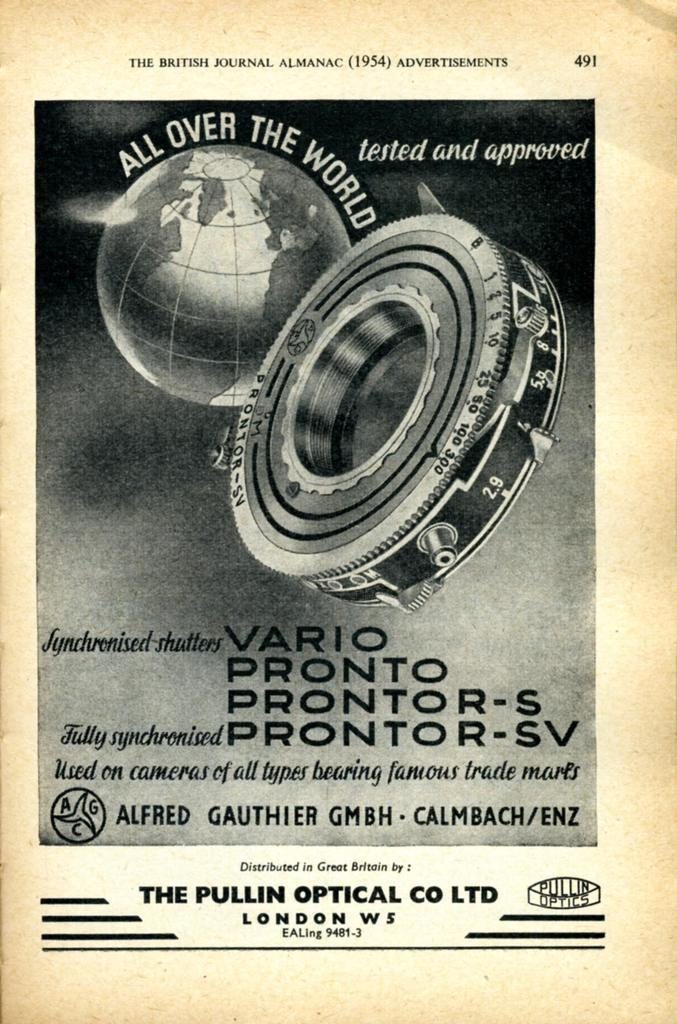What is the color scheme of the image? The image is black and white. What is the main object in the middle of the image? There is a globe in the middle of the image. What can be found on the surface of the globe? There are names of persons on the globe. How many bikes are parked next to the globe in the image? There are no bikes present in the image; it only features a black and white globe with names of persons on it. What type of jelly can be seen dripping from the names on the globe? There is no jelly present in the image; it only features a black and white globe with names of persons on it. 